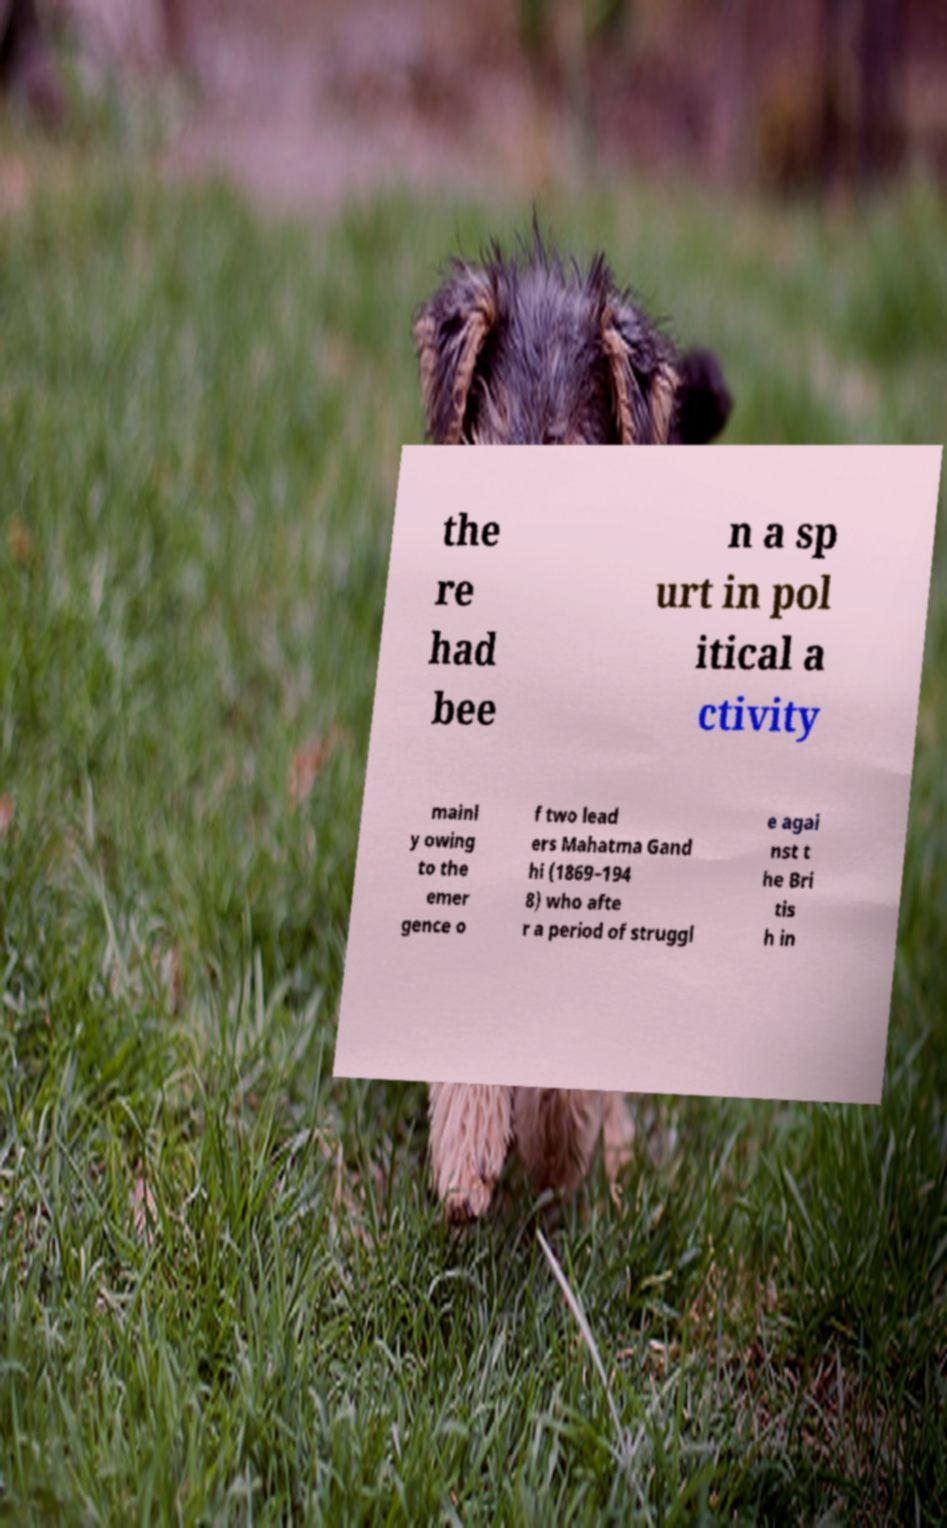Could you assist in decoding the text presented in this image and type it out clearly? the re had bee n a sp urt in pol itical a ctivity mainl y owing to the emer gence o f two lead ers Mahatma Gand hi (1869–194 8) who afte r a period of struggl e agai nst t he Bri tis h in 